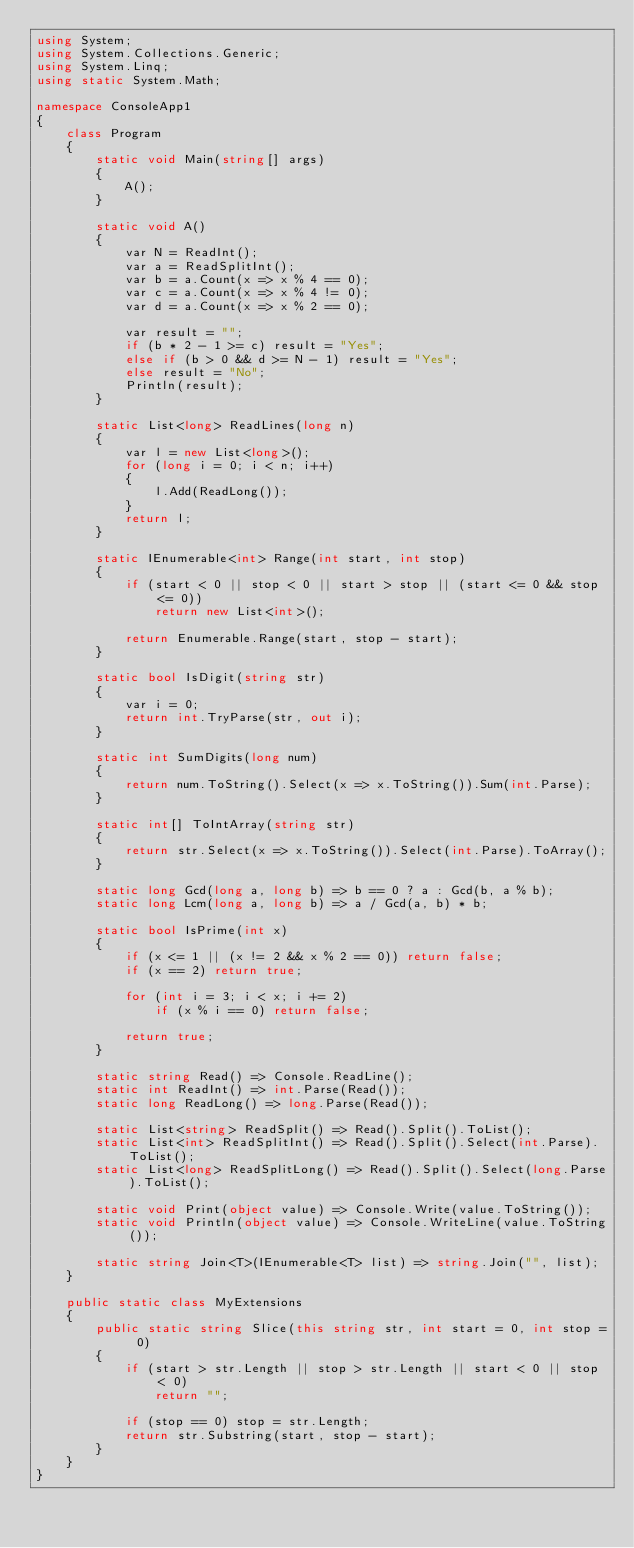<code> <loc_0><loc_0><loc_500><loc_500><_C#_>using System;
using System.Collections.Generic;
using System.Linq;
using static System.Math;

namespace ConsoleApp1
{
    class Program
    {
        static void Main(string[] args)
        {
            A();
        }

        static void A()
        {
            var N = ReadInt();
            var a = ReadSplitInt();
            var b = a.Count(x => x % 4 == 0);
            var c = a.Count(x => x % 4 != 0);
            var d = a.Count(x => x % 2 == 0);

            var result = "";
            if (b * 2 - 1 >= c) result = "Yes";
            else if (b > 0 && d >= N - 1) result = "Yes";
            else result = "No";
            Println(result);
        }

        static List<long> ReadLines(long n)
        {
            var l = new List<long>();
            for (long i = 0; i < n; i++)
            {
                l.Add(ReadLong());
            }
            return l;
        }

        static IEnumerable<int> Range(int start, int stop)
        {
            if (start < 0 || stop < 0 || start > stop || (start <= 0 && stop <= 0))
                return new List<int>();

            return Enumerable.Range(start, stop - start);
        }

        static bool IsDigit(string str)
        {
            var i = 0;
            return int.TryParse(str, out i);
        }

        static int SumDigits(long num)
        {
            return num.ToString().Select(x => x.ToString()).Sum(int.Parse);
        }

        static int[] ToIntArray(string str)
        {
            return str.Select(x => x.ToString()).Select(int.Parse).ToArray();
        }

        static long Gcd(long a, long b) => b == 0 ? a : Gcd(b, a % b);
        static long Lcm(long a, long b) => a / Gcd(a, b) * b;

        static bool IsPrime(int x)
        {
            if (x <= 1 || (x != 2 && x % 2 == 0)) return false;
            if (x == 2) return true;

            for (int i = 3; i < x; i += 2)
                if (x % i == 0) return false;

            return true;
        }

        static string Read() => Console.ReadLine();
        static int ReadInt() => int.Parse(Read());
        static long ReadLong() => long.Parse(Read());

        static List<string> ReadSplit() => Read().Split().ToList();
        static List<int> ReadSplitInt() => Read().Split().Select(int.Parse).ToList();
        static List<long> ReadSplitLong() => Read().Split().Select(long.Parse).ToList();

        static void Print(object value) => Console.Write(value.ToString());
        static void Println(object value) => Console.WriteLine(value.ToString());

        static string Join<T>(IEnumerable<T> list) => string.Join("", list);
    }

    public static class MyExtensions
    {
        public static string Slice(this string str, int start = 0, int stop = 0)
        {
            if (start > str.Length || stop > str.Length || start < 0 || stop < 0)
                return "";

            if (stop == 0) stop = str.Length;
            return str.Substring(start, stop - start);
        }
    }
}</code> 